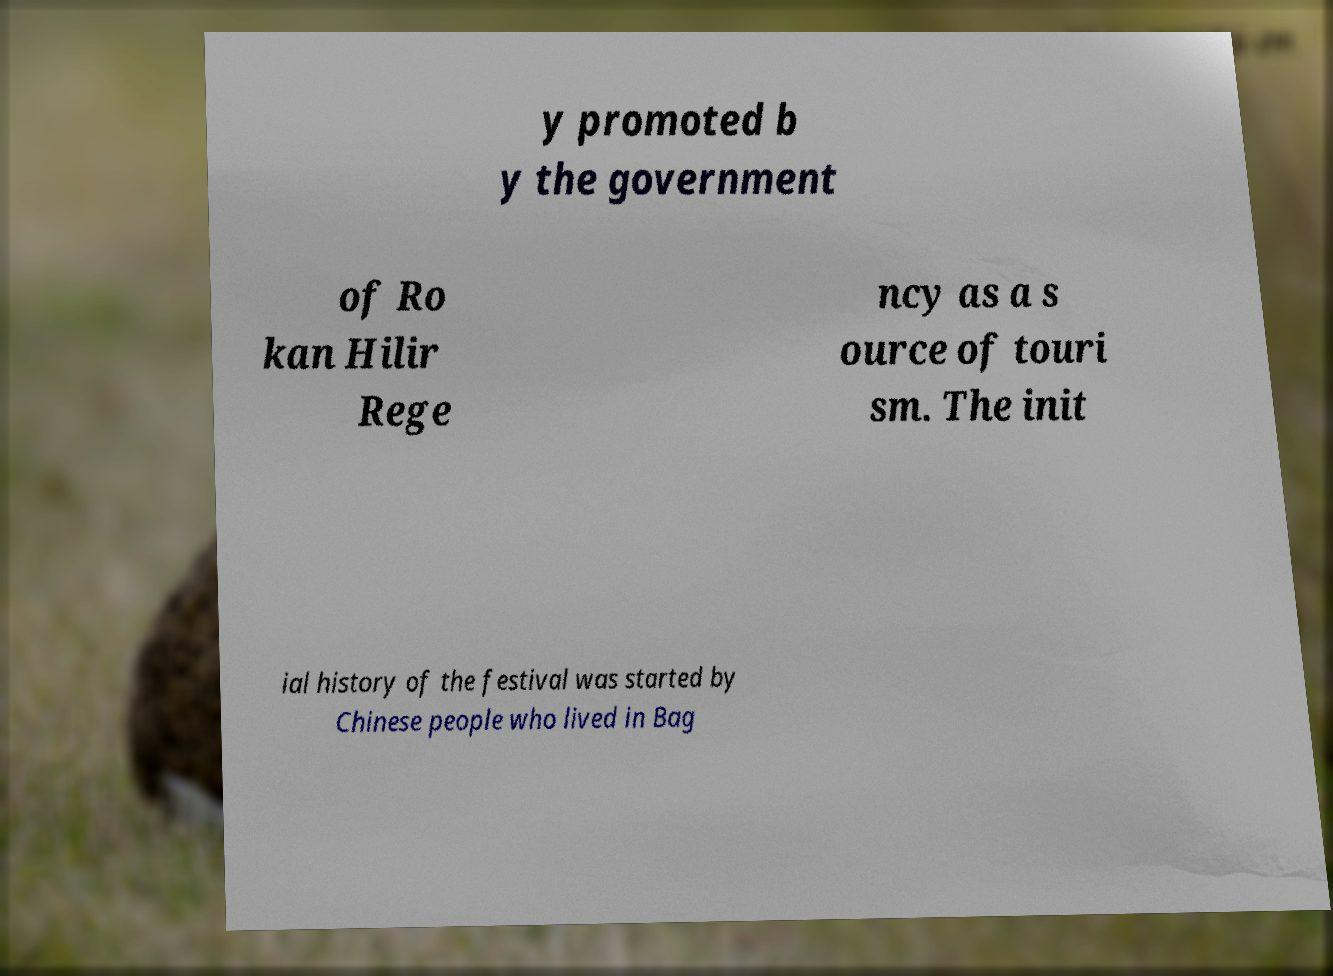Please identify and transcribe the text found in this image. y promoted b y the government of Ro kan Hilir Rege ncy as a s ource of touri sm. The init ial history of the festival was started by Chinese people who lived in Bag 